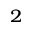<formula> <loc_0><loc_0><loc_500><loc_500>^ { 2 }</formula> 